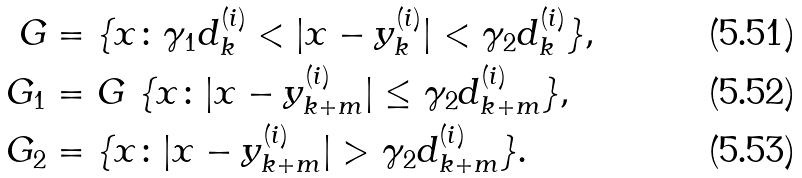Convert formula to latex. <formula><loc_0><loc_0><loc_500><loc_500>G & = \{ x \colon \gamma _ { 1 } d ^ { ( i ) } _ { k } < | x - y _ { k } ^ { ( i ) } | < \gamma _ { 2 } d _ { k } ^ { ( i ) } \} , \\ G _ { 1 } & = G \ \{ x \colon | x - y _ { k + m } ^ { ( i ) } | \leq \gamma _ { 2 } d _ { k + m } ^ { ( i ) } \} , \\ G _ { 2 } & = \{ x \colon | x - y _ { k + m } ^ { ( i ) } | > \gamma _ { 2 } d _ { k + m } ^ { ( i ) } \} .</formula> 